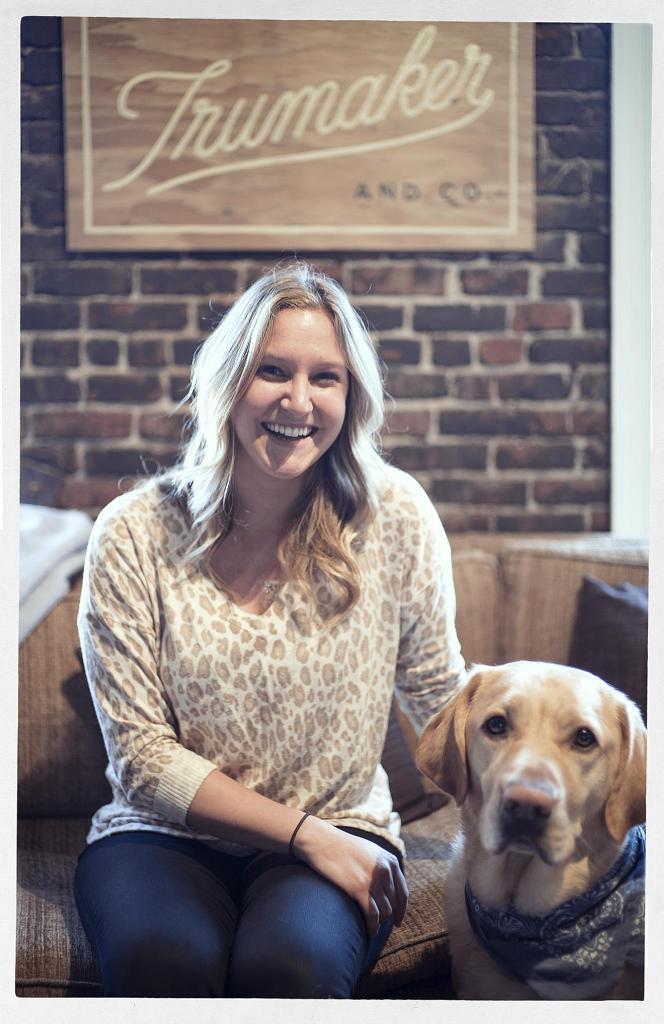In one or two sentences, can you explain what this image depicts? This image consists of a woman sitting on the sofa and having a smile on her face. In front of that a dog is standing at the bottom. The background wall is of bricks and on that a board is there of trumaker. This image is taken inside a room. 